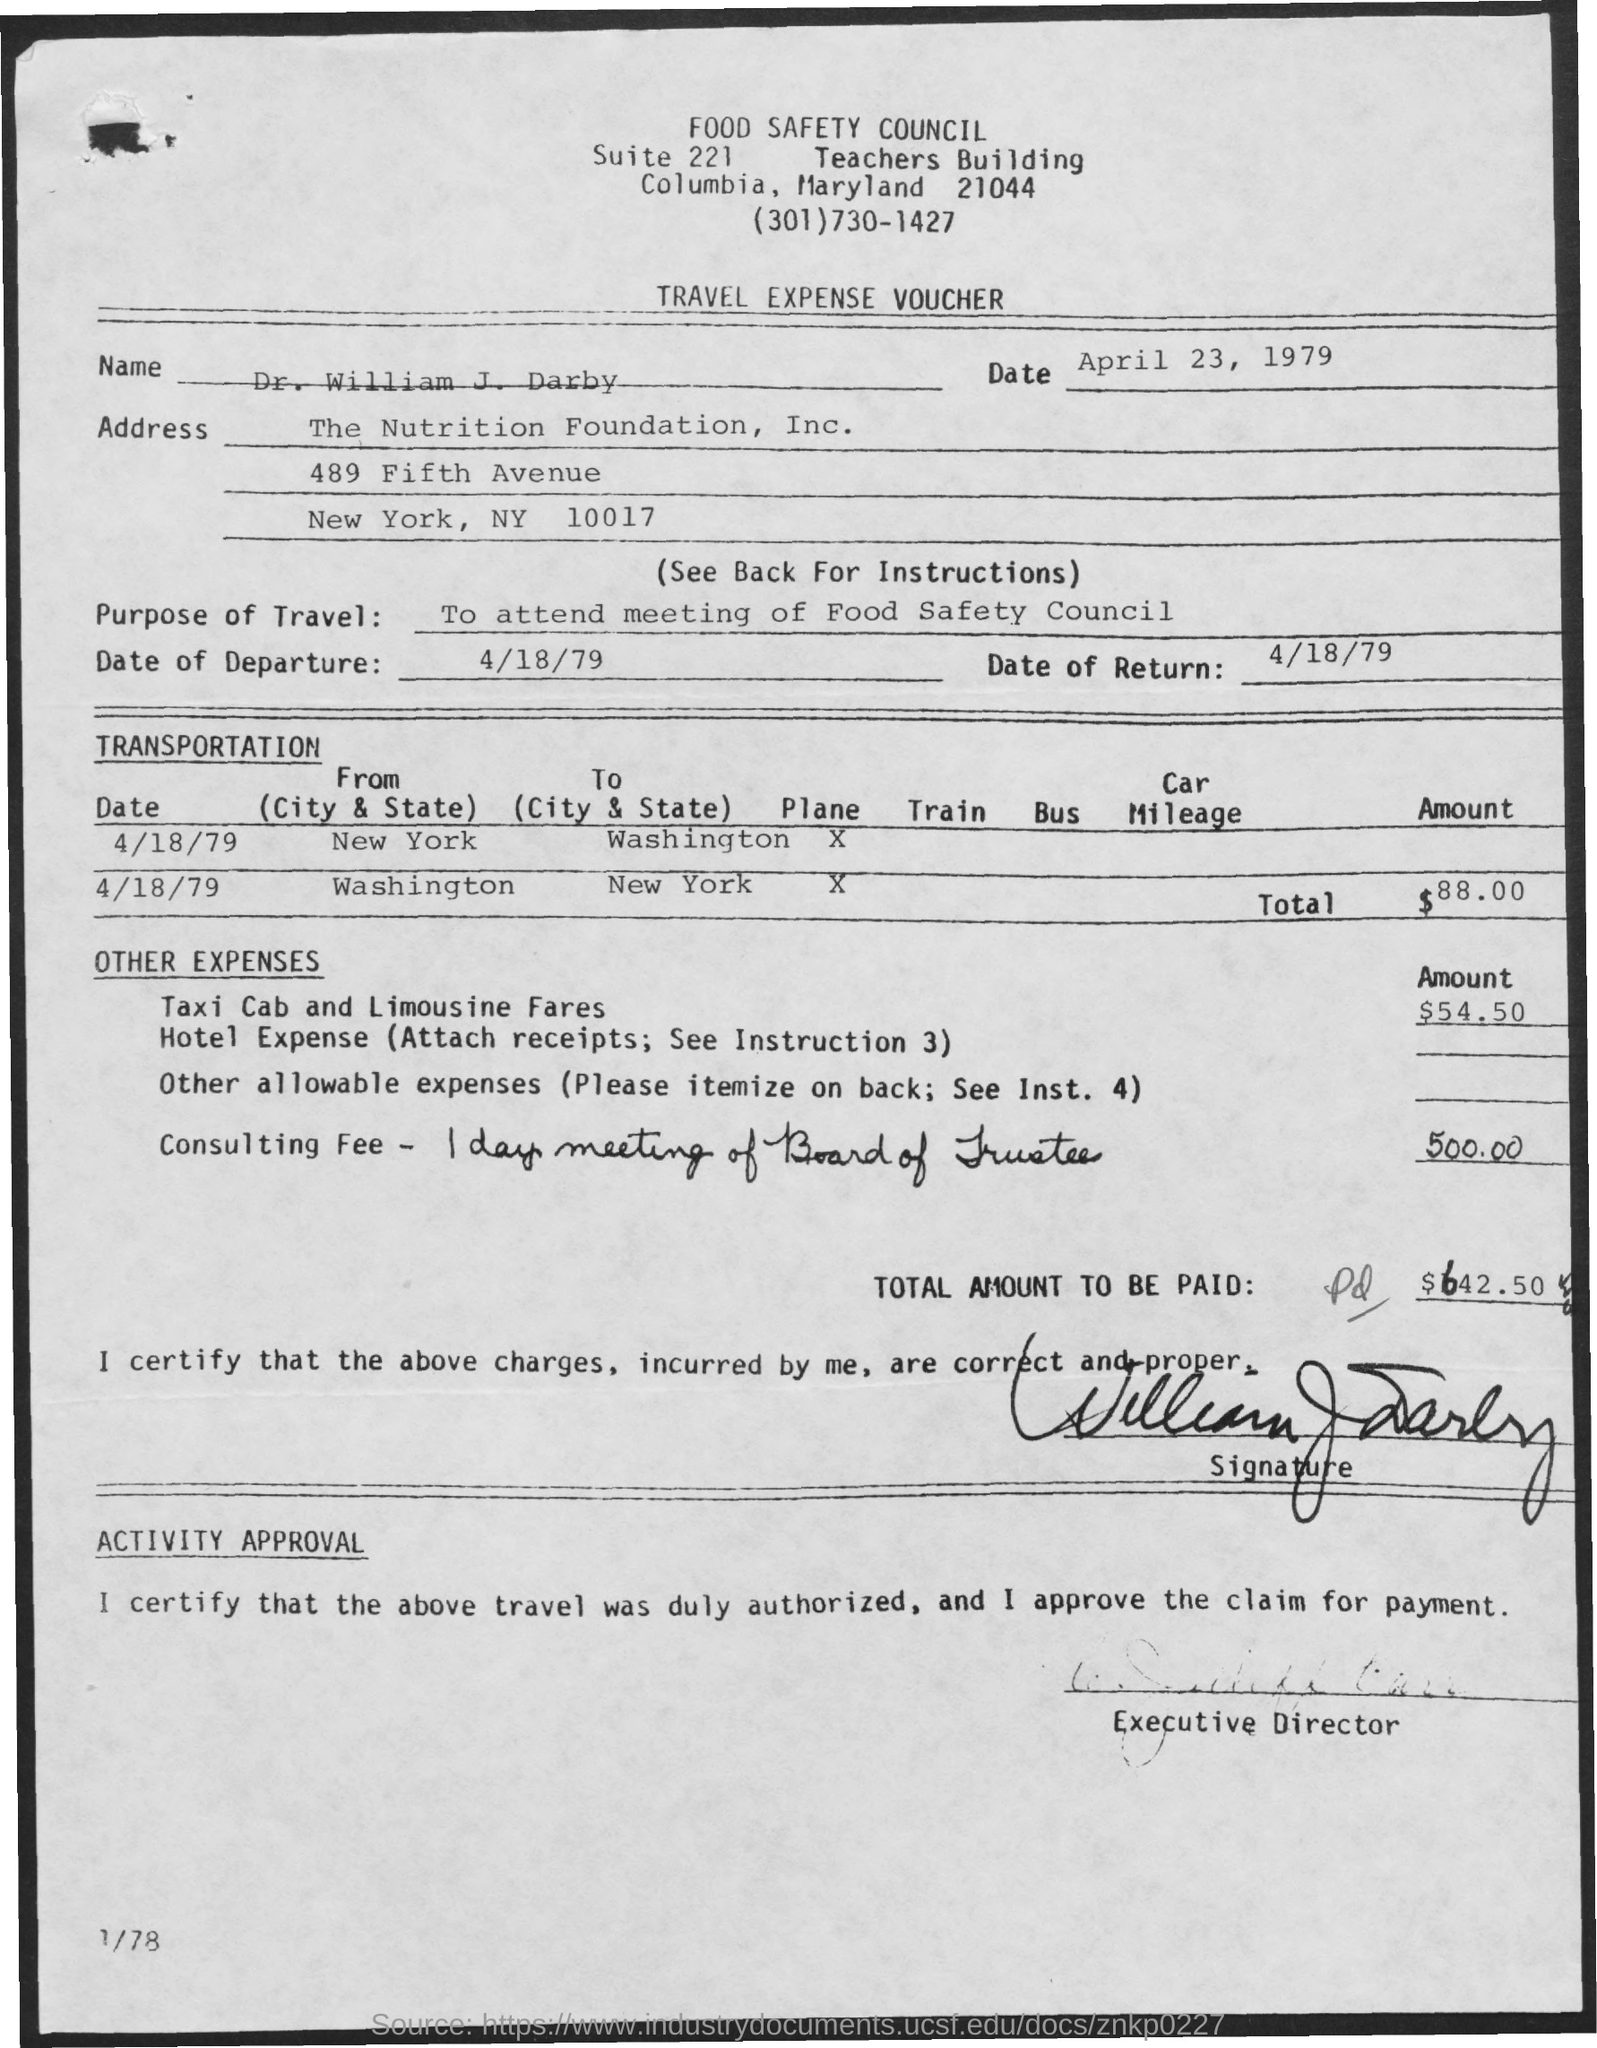What was the mode of transportation used for the journey to New York? The mode of transportation used to travel to New York was by plane. 